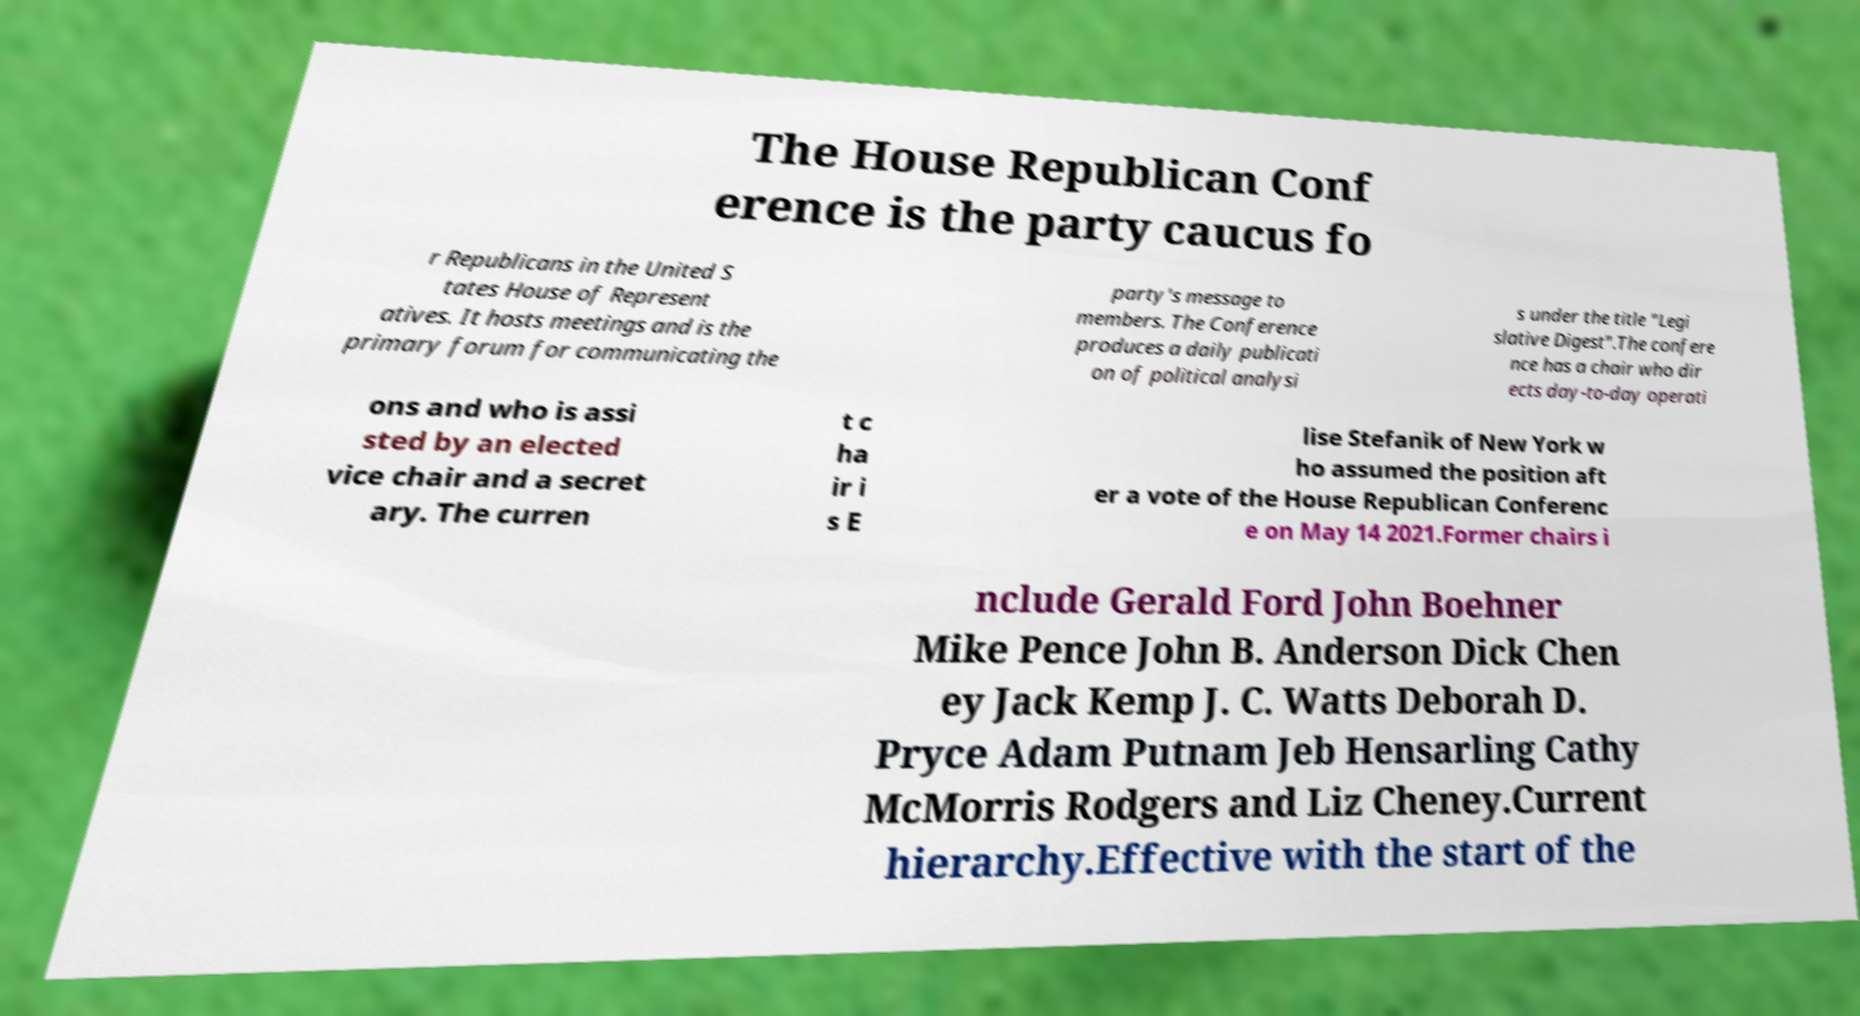Can you read and provide the text displayed in the image?This photo seems to have some interesting text. Can you extract and type it out for me? The House Republican Conf erence is the party caucus fo r Republicans in the United S tates House of Represent atives. It hosts meetings and is the primary forum for communicating the party's message to members. The Conference produces a daily publicati on of political analysi s under the title "Legi slative Digest".The confere nce has a chair who dir ects day-to-day operati ons and who is assi sted by an elected vice chair and a secret ary. The curren t c ha ir i s E lise Stefanik of New York w ho assumed the position aft er a vote of the House Republican Conferenc e on May 14 2021.Former chairs i nclude Gerald Ford John Boehner Mike Pence John B. Anderson Dick Chen ey Jack Kemp J. C. Watts Deborah D. Pryce Adam Putnam Jeb Hensarling Cathy McMorris Rodgers and Liz Cheney.Current hierarchy.Effective with the start of the 